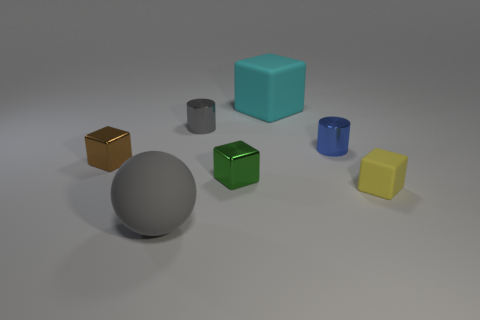Add 2 small brown blocks. How many objects exist? 9 Subtract all blocks. How many objects are left? 3 Subtract 0 cyan cylinders. How many objects are left? 7 Subtract all large green matte cubes. Subtract all tiny gray metal cylinders. How many objects are left? 6 Add 4 tiny gray cylinders. How many tiny gray cylinders are left? 5 Add 6 small brown rubber things. How many small brown rubber things exist? 6 